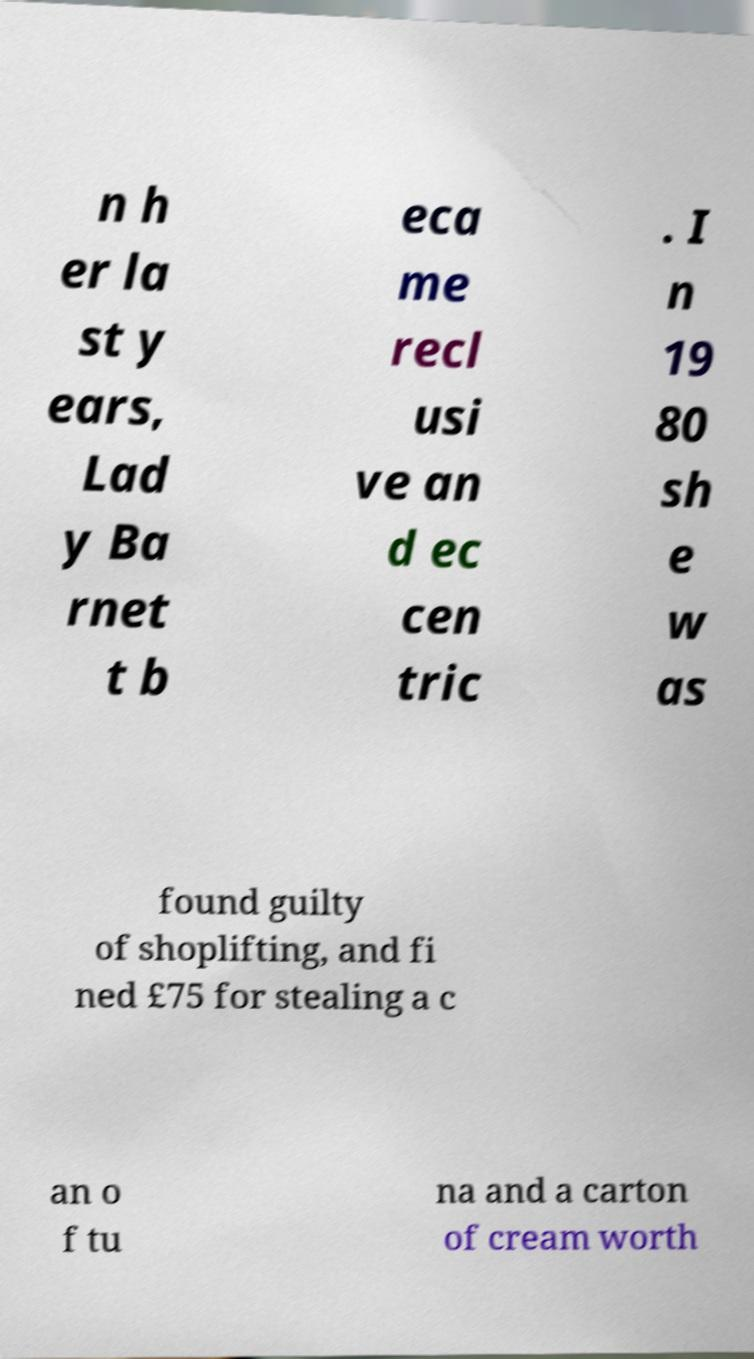Please read and relay the text visible in this image. What does it say? n h er la st y ears, Lad y Ba rnet t b eca me recl usi ve an d ec cen tric . I n 19 80 sh e w as found guilty of shoplifting, and fi ned £75 for stealing a c an o f tu na and a carton of cream worth 